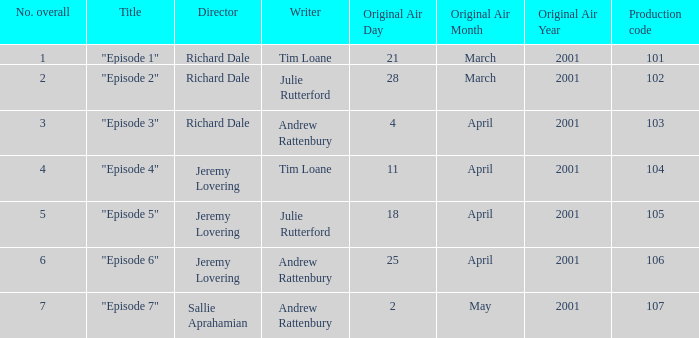What is the highest production code of an episode written by Tim Loane? 104.0. 